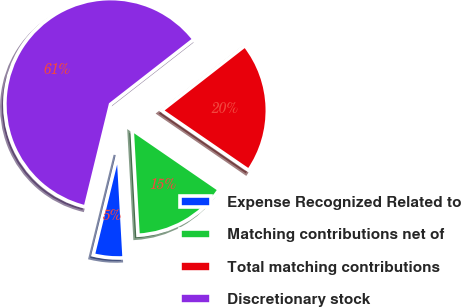Convert chart. <chart><loc_0><loc_0><loc_500><loc_500><pie_chart><fcel>Expense Recognized Related to<fcel>Matching contributions net of<fcel>Total matching contributions<fcel>Discretionary stock<nl><fcel>4.7%<fcel>14.53%<fcel>20.12%<fcel>60.65%<nl></chart> 